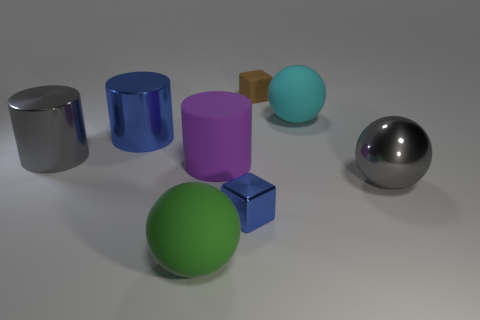How many yellow objects are either large things or cubes?
Your answer should be very brief. 0. What is the size of the blue cube?
Ensure brevity in your answer.  Small. How many metal things are either small blue blocks or brown objects?
Offer a very short reply. 1. Is the number of tiny brown cubes less than the number of cylinders?
Make the answer very short. Yes. What number of other things are the same material as the small blue block?
Provide a short and direct response. 3. What size is the other matte thing that is the same shape as the cyan rubber thing?
Give a very brief answer. Large. Do the blue object that is behind the tiny blue shiny cube and the small cube that is behind the purple rubber cylinder have the same material?
Your answer should be very brief. No. Are there fewer gray metal objects that are to the right of the green rubber thing than gray cubes?
Your answer should be compact. No. What color is the other object that is the same shape as the brown matte object?
Give a very brief answer. Blue. Do the rubber ball that is left of the cyan sphere and the large purple rubber object have the same size?
Offer a very short reply. Yes. 